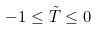Convert formula to latex. <formula><loc_0><loc_0><loc_500><loc_500>- 1 \leq \tilde { T } \leq 0</formula> 